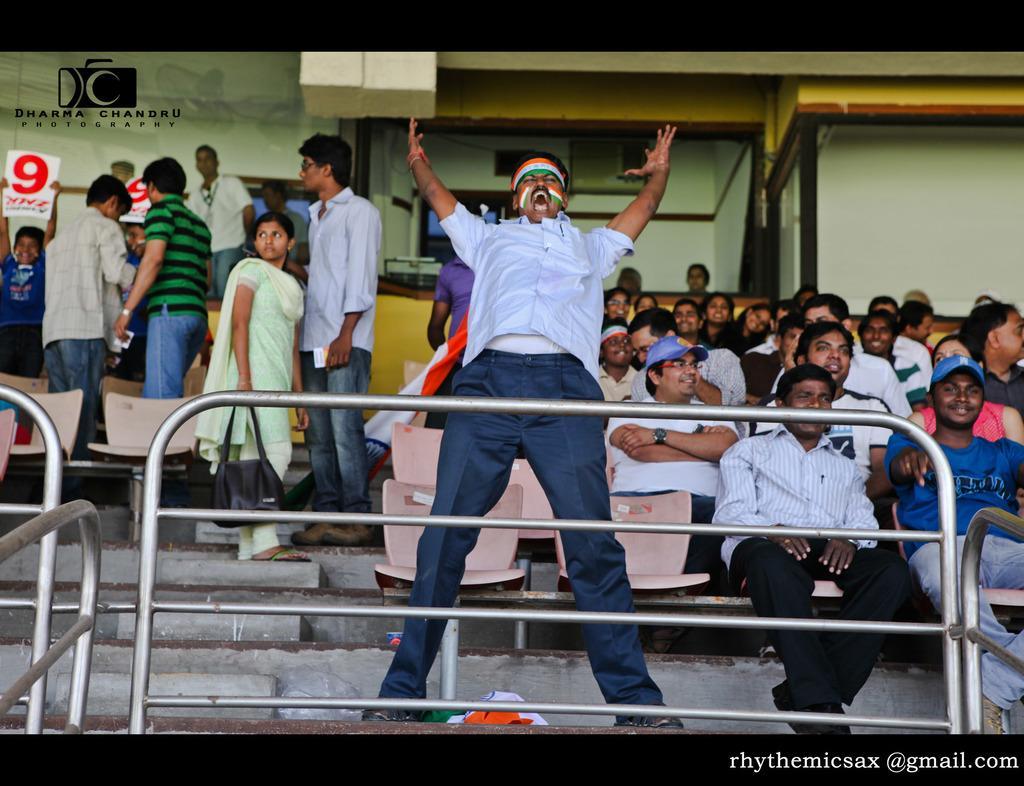Can you describe this image briefly? In this picture we can see the people. Few people are sitting on the chairs and few people are standing. We can see stairs, chairs, objects, railings. At the bottom portion of the picture we can see flag. On the left side of the picture we can see people are holding boards. In the bottom right corner of the picture we can see watermark. 